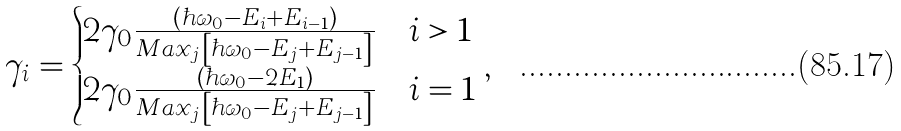Convert formula to latex. <formula><loc_0><loc_0><loc_500><loc_500>\gamma _ { i } = \begin{cases} 2 \gamma _ { 0 } \frac { \left ( \hbar { \omega } _ { 0 } - E _ { i } + E _ { i - 1 } \right ) } { M a x _ { j } \left [ \hbar { \omega } _ { 0 } - E _ { j } + E _ { j - 1 } \right ] } & i > 1 \\ 2 \gamma _ { 0 } \frac { \left ( \hbar { \omega } _ { 0 } - 2 E _ { 1 } \right ) } { M a x _ { j } \left [ \hbar { \omega } _ { 0 } - E _ { j } + E _ { j - 1 } \right ] } & i = 1 \end{cases} ,</formula> 